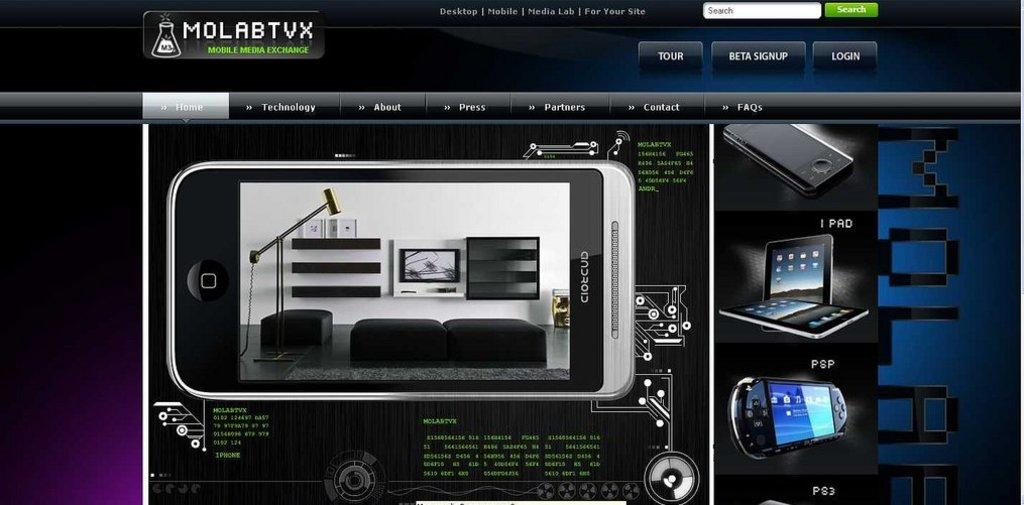Provide a one-sentence caption for the provided image. A webpage, entitled MolabTVX, shows the specifications of a phone. 